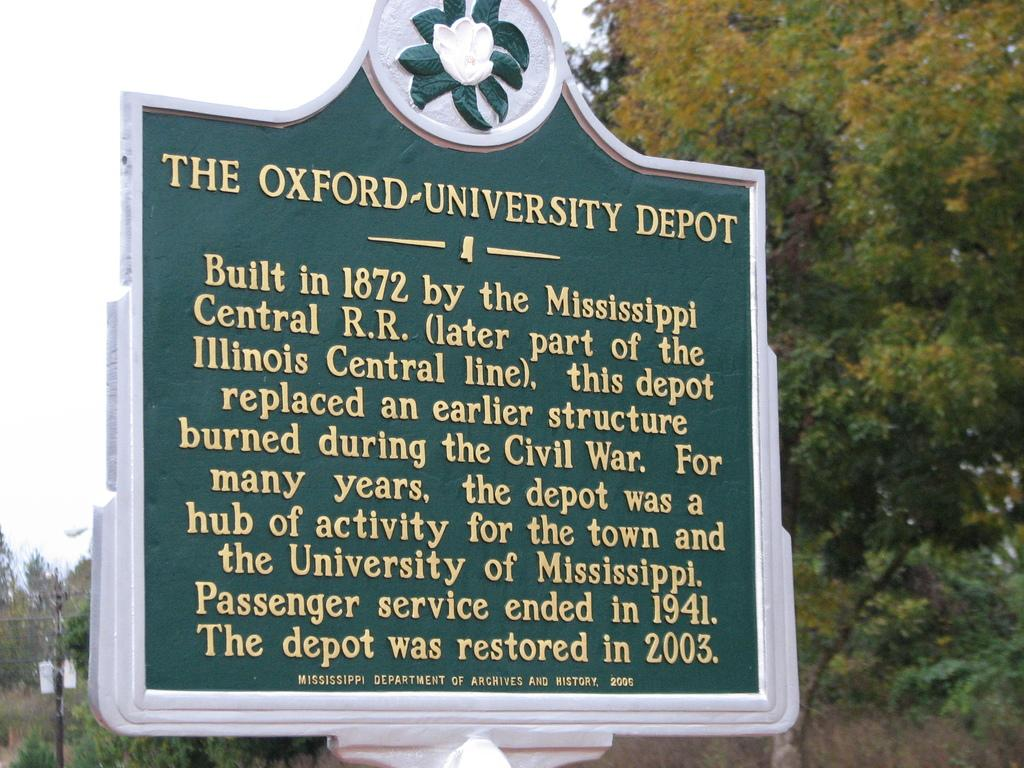What is on the board that is visible in the image? There is text on the board in the image. What can be seen in the background of the image? There are trees and a current pole in the background of the image. What type of shoes are hanging from the cactus in the image? There is no cactus or shoes present in the image. 